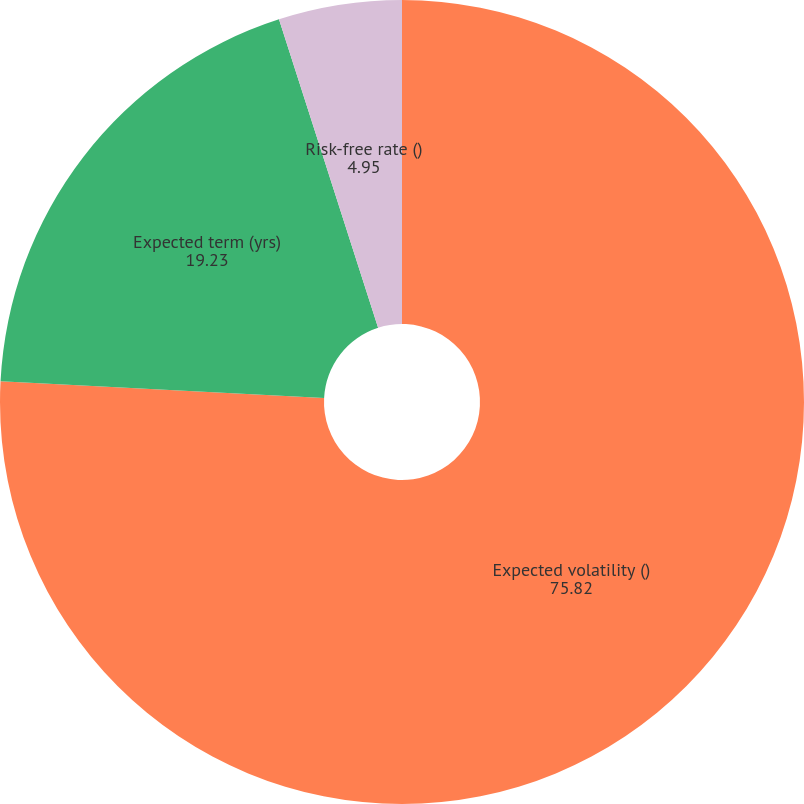Convert chart to OTSL. <chart><loc_0><loc_0><loc_500><loc_500><pie_chart><fcel>Expected volatility ()<fcel>Expected term (yrs)<fcel>Risk-free rate ()<nl><fcel>75.82%<fcel>19.23%<fcel>4.95%<nl></chart> 